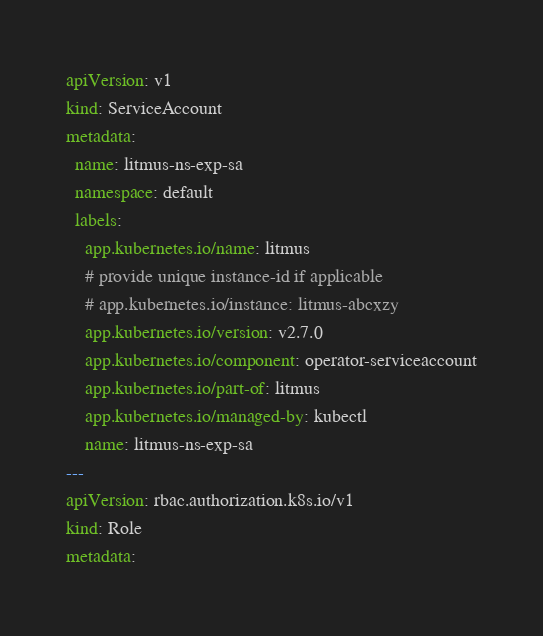<code> <loc_0><loc_0><loc_500><loc_500><_YAML_>apiVersion: v1
kind: ServiceAccount
metadata:
  name: litmus-ns-exp-sa
  namespace: default
  labels:
    app.kubernetes.io/name: litmus
    # provide unique instance-id if applicable
    # app.kubernetes.io/instance: litmus-abcxzy
    app.kubernetes.io/version: v2.7.0
    app.kubernetes.io/component: operator-serviceaccount
    app.kubernetes.io/part-of: litmus
    app.kubernetes.io/managed-by: kubectl
    name: litmus-ns-exp-sa
---
apiVersion: rbac.authorization.k8s.io/v1
kind: Role
metadata:</code> 